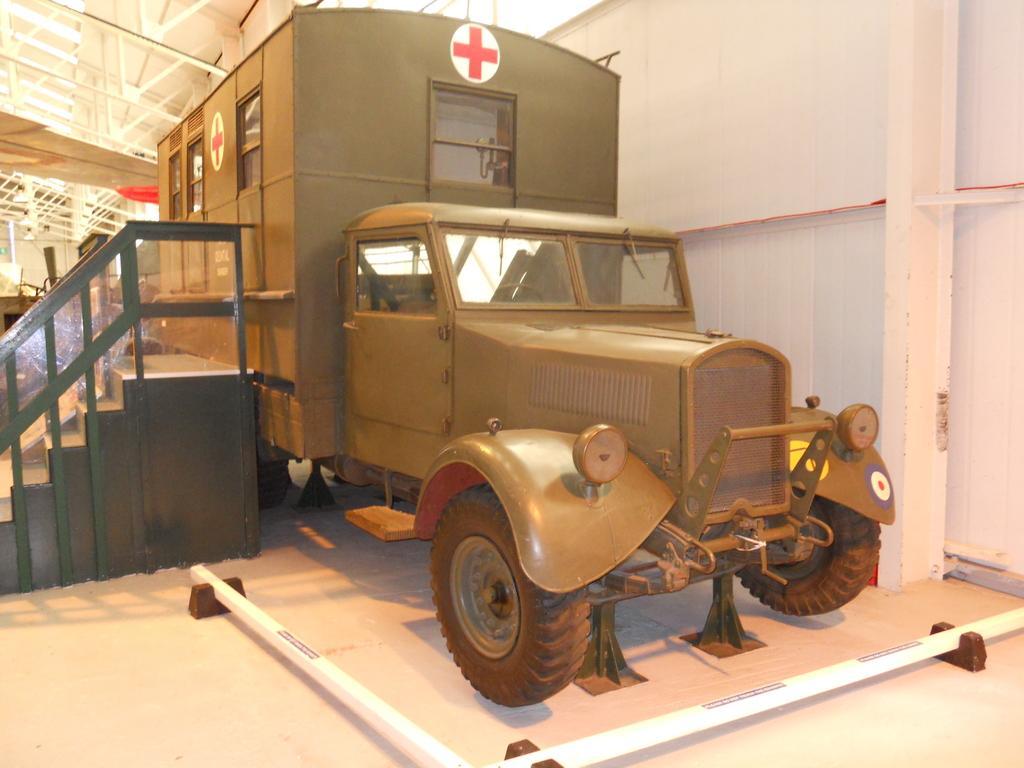Can you describe this image briefly? In this image in the center there is one vehicle and on the left side there are some stairs and in the background there are some wooden sticks and a wall, in the foreground there is a wall and pillar. At the bottom there is a floor. 